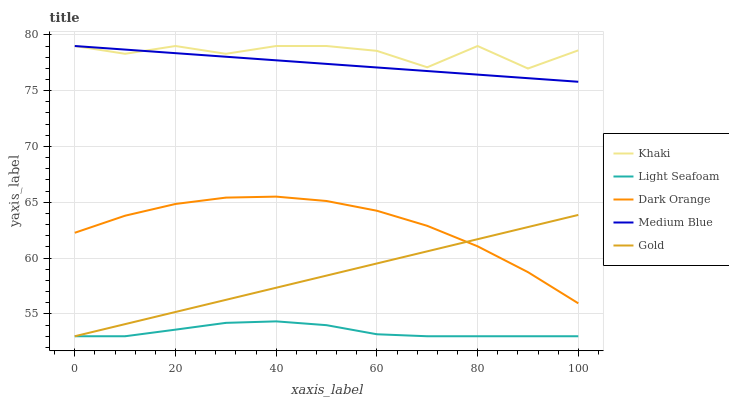Does Light Seafoam have the minimum area under the curve?
Answer yes or no. Yes. Does Khaki have the maximum area under the curve?
Answer yes or no. Yes. Does Medium Blue have the minimum area under the curve?
Answer yes or no. No. Does Medium Blue have the maximum area under the curve?
Answer yes or no. No. Is Medium Blue the smoothest?
Answer yes or no. Yes. Is Khaki the roughest?
Answer yes or no. Yes. Is Khaki the smoothest?
Answer yes or no. No. Is Medium Blue the roughest?
Answer yes or no. No. Does Medium Blue have the lowest value?
Answer yes or no. No. Does Gold have the highest value?
Answer yes or no. No. Is Light Seafoam less than Khaki?
Answer yes or no. Yes. Is Khaki greater than Gold?
Answer yes or no. Yes. Does Light Seafoam intersect Khaki?
Answer yes or no. No. 